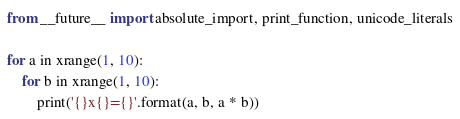<code> <loc_0><loc_0><loc_500><loc_500><_Python_>from __future__ import absolute_import, print_function, unicode_literals

for a in xrange(1, 10):
    for b in xrange(1, 10):
        print('{}x{}={}'.format(a, b, a * b))</code> 